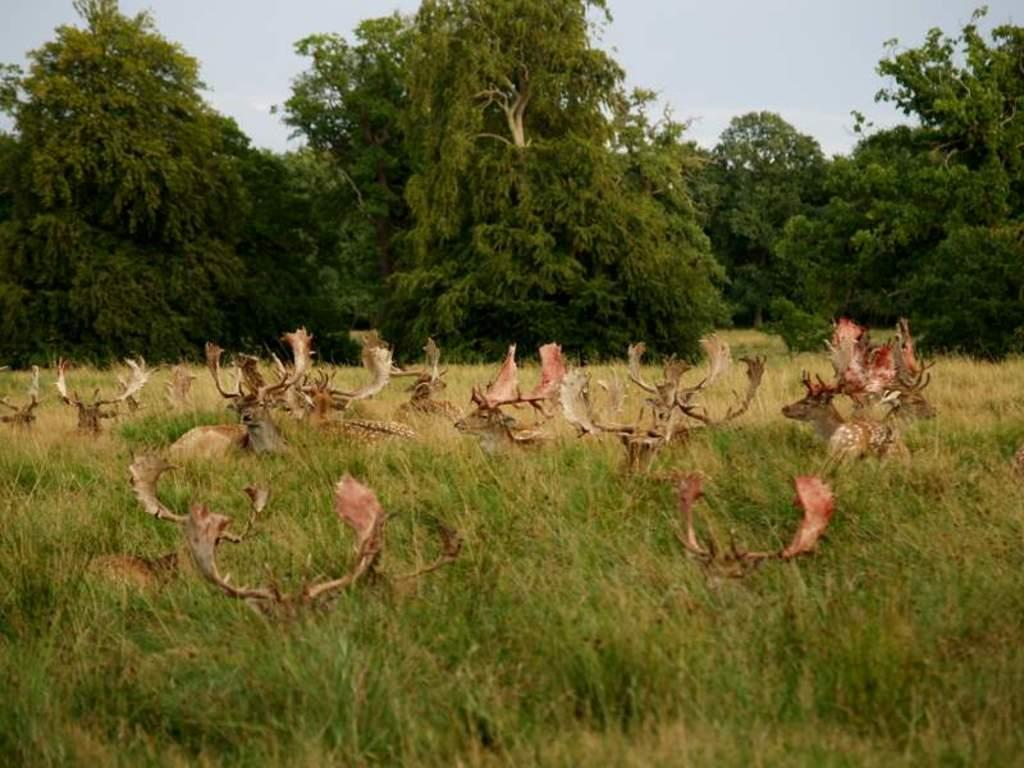What animals are in the center of the image? There are deers in the center of the image. What else is in the center of the image besides the deers? There are plants in the center of the image. What can be seen in the background of the image? There are trees in the background of the image. What is visible at the top of the image? The sky is visible at the top of the image. What type of bone can be seen in the image? There is no bone present in the image. How many oranges are visible in the image? There are no oranges present in the image. 